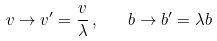Convert formula to latex. <formula><loc_0><loc_0><loc_500><loc_500>v \rightarrow v ^ { \prime } = \frac { v } { \lambda } \, , \quad b \rightarrow b ^ { \prime } = \lambda b</formula> 